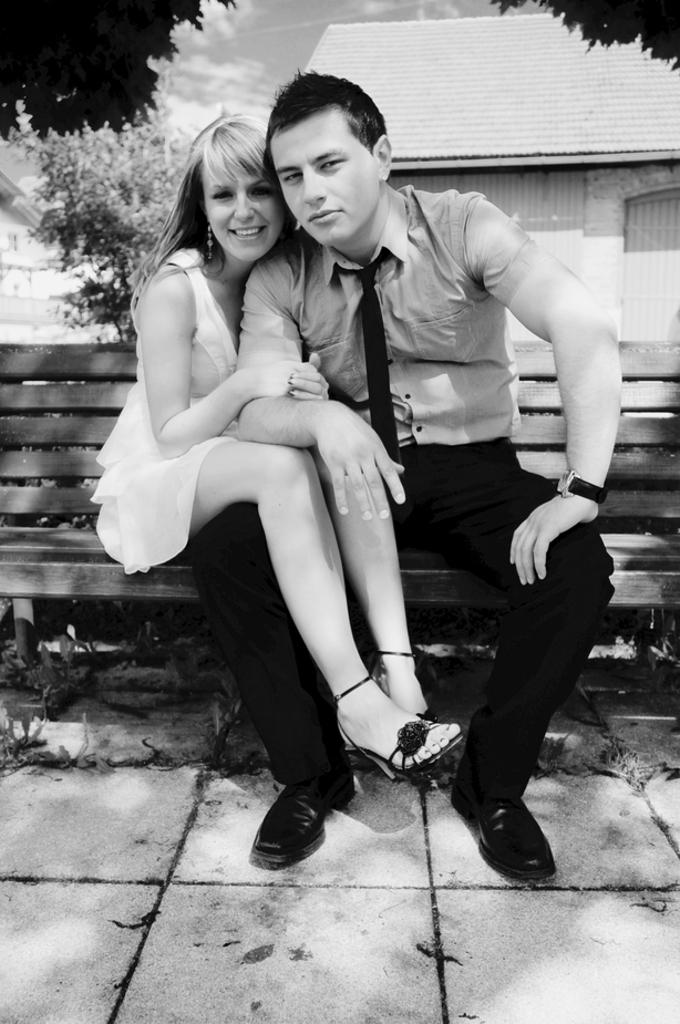How many people are sitting on the bench in the image? There are two persons sitting on the bench in the image. What is the facial expression of the persons? The persons are smiling. What can be seen behind the bench? There are trees and buildings behind the bench. What is visible in the sky at the top of the image? Clouds are visible in the sky at the top of the image. Can you tell me how many brothers are present in the image? There is no information about brothers in the image; it only shows two persons sitting on a bench. What is the relationship between the persons and the moon in the image? There is no moon present in the image; it only features clouds in the sky. 